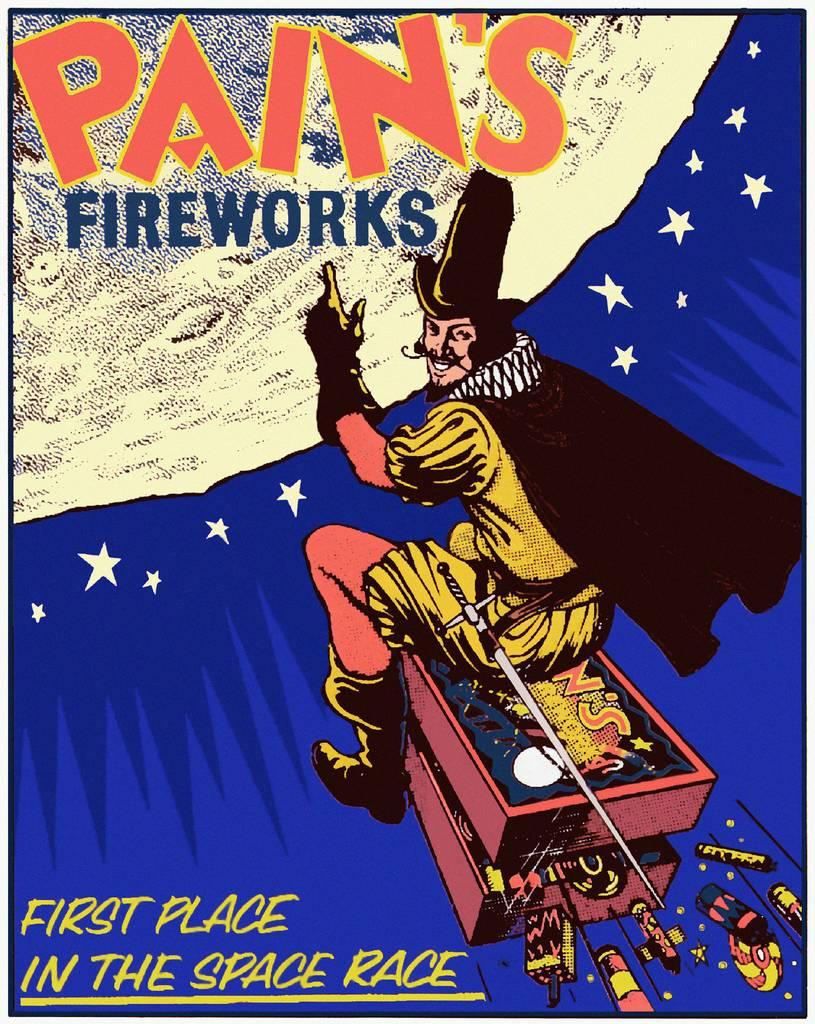<image>
Summarize the visual content of the image. a poster that says 'first place in the space race' on it 